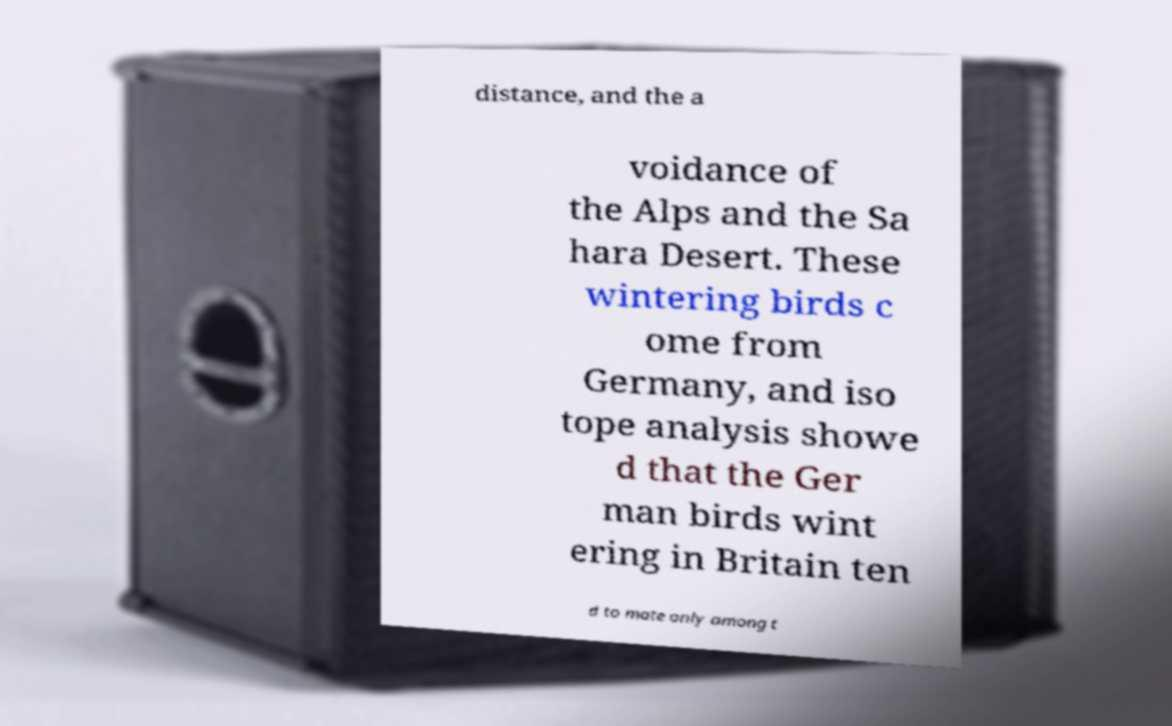There's text embedded in this image that I need extracted. Can you transcribe it verbatim? distance, and the a voidance of the Alps and the Sa hara Desert. These wintering birds c ome from Germany, and iso tope analysis showe d that the Ger man birds wint ering in Britain ten d to mate only among t 